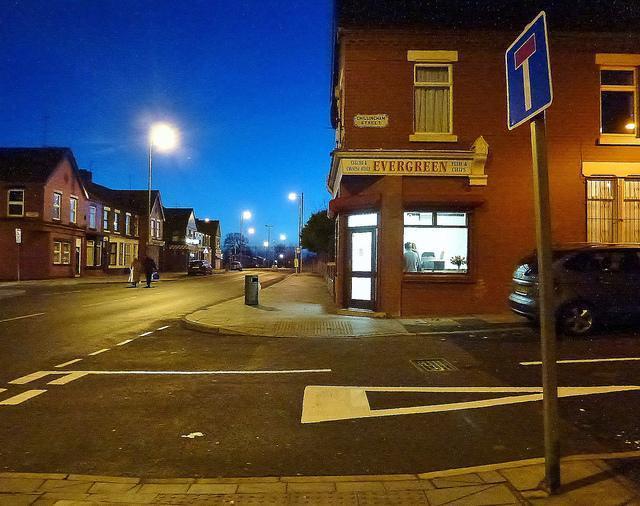How many people are in the middle of the street?
Give a very brief answer. 2. How many light poles in the picture?
Give a very brief answer. 6. 